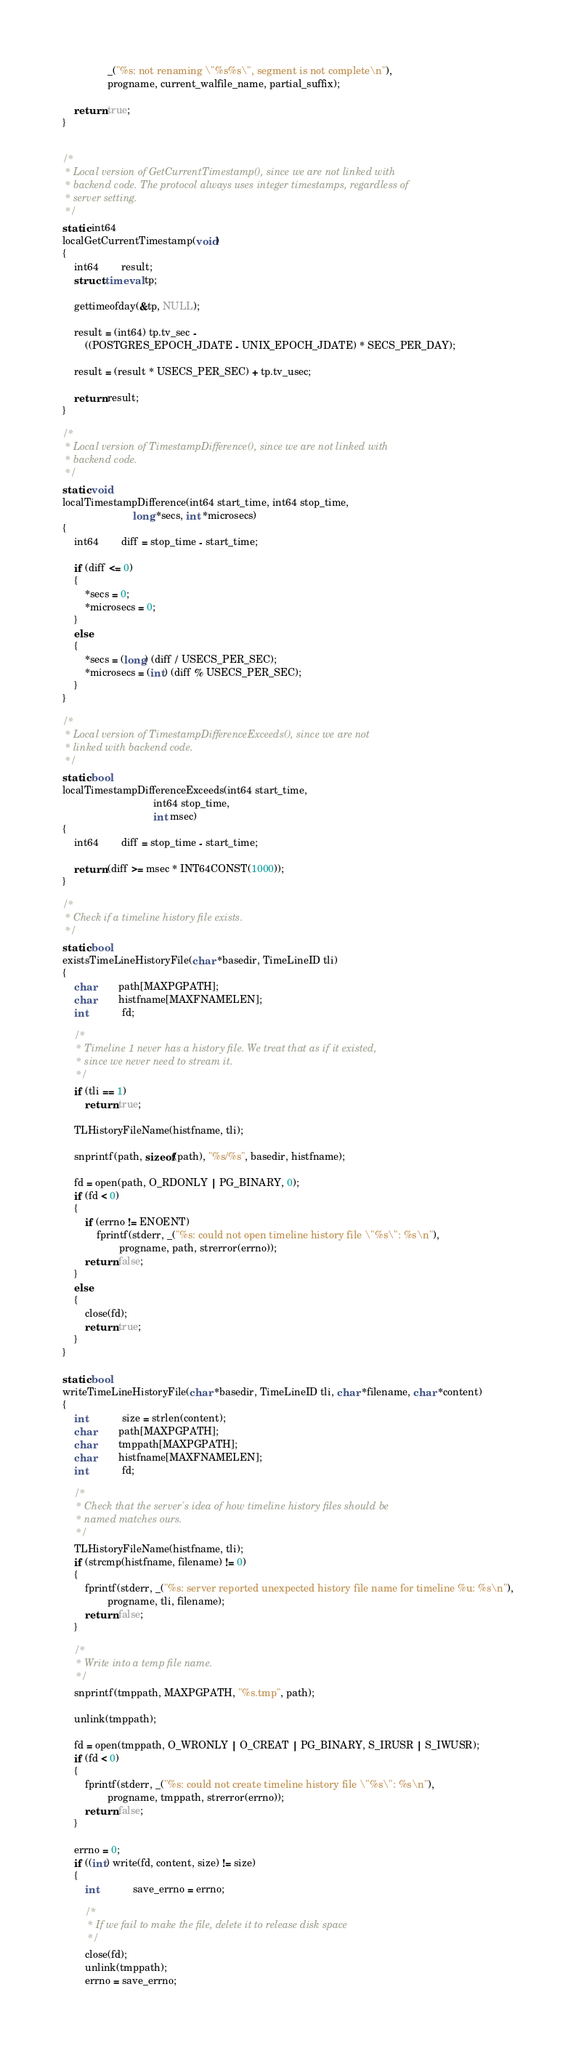Convert code to text. <code><loc_0><loc_0><loc_500><loc_500><_C_>				_("%s: not renaming \"%s%s\", segment is not complete\n"),
				progname, current_walfile_name, partial_suffix);

	return true;
}


/*
 * Local version of GetCurrentTimestamp(), since we are not linked with
 * backend code. The protocol always uses integer timestamps, regardless of
 * server setting.
 */
static int64
localGetCurrentTimestamp(void)
{
	int64		result;
	struct timeval tp;

	gettimeofday(&tp, NULL);

	result = (int64) tp.tv_sec -
		((POSTGRES_EPOCH_JDATE - UNIX_EPOCH_JDATE) * SECS_PER_DAY);

	result = (result * USECS_PER_SEC) + tp.tv_usec;

	return result;
}

/*
 * Local version of TimestampDifference(), since we are not linked with
 * backend code.
 */
static void
localTimestampDifference(int64 start_time, int64 stop_time,
						 long *secs, int *microsecs)
{
	int64		diff = stop_time - start_time;

	if (diff <= 0)
	{
		*secs = 0;
		*microsecs = 0;
	}
	else
	{
		*secs = (long) (diff / USECS_PER_SEC);
		*microsecs = (int) (diff % USECS_PER_SEC);
	}
}

/*
 * Local version of TimestampDifferenceExceeds(), since we are not
 * linked with backend code.
 */
static bool
localTimestampDifferenceExceeds(int64 start_time,
								int64 stop_time,
								int msec)
{
	int64		diff = stop_time - start_time;

	return (diff >= msec * INT64CONST(1000));
}

/*
 * Check if a timeline history file exists.
 */
static bool
existsTimeLineHistoryFile(char *basedir, TimeLineID tli)
{
	char		path[MAXPGPATH];
	char		histfname[MAXFNAMELEN];
	int			fd;

	/*
	 * Timeline 1 never has a history file. We treat that as if it existed,
	 * since we never need to stream it.
	 */
	if (tli == 1)
		return true;

	TLHistoryFileName(histfname, tli);

	snprintf(path, sizeof(path), "%s/%s", basedir, histfname);

	fd = open(path, O_RDONLY | PG_BINARY, 0);
	if (fd < 0)
	{
		if (errno != ENOENT)
			fprintf(stderr, _("%s: could not open timeline history file \"%s\": %s\n"),
					progname, path, strerror(errno));
		return false;
	}
	else
	{
		close(fd);
		return true;
	}
}

static bool
writeTimeLineHistoryFile(char *basedir, TimeLineID tli, char *filename, char *content)
{
	int			size = strlen(content);
	char		path[MAXPGPATH];
	char		tmppath[MAXPGPATH];
	char		histfname[MAXFNAMELEN];
	int			fd;

	/*
	 * Check that the server's idea of how timeline history files should be
	 * named matches ours.
	 */
	TLHistoryFileName(histfname, tli);
	if (strcmp(histfname, filename) != 0)
	{
		fprintf(stderr, _("%s: server reported unexpected history file name for timeline %u: %s\n"),
				progname, tli, filename);
		return false;
	}

	/*
	 * Write into a temp file name.
	 */
	snprintf(tmppath, MAXPGPATH, "%s.tmp", path);

	unlink(tmppath);

	fd = open(tmppath, O_WRONLY | O_CREAT | PG_BINARY, S_IRUSR | S_IWUSR);
	if (fd < 0)
	{
		fprintf(stderr, _("%s: could not create timeline history file \"%s\": %s\n"),
				progname, tmppath, strerror(errno));
		return false;
	}

	errno = 0;
	if ((int) write(fd, content, size) != size)
	{
		int			save_errno = errno;

		/*
		 * If we fail to make the file, delete it to release disk space
		 */
		close(fd);
		unlink(tmppath);
		errno = save_errno;
</code> 